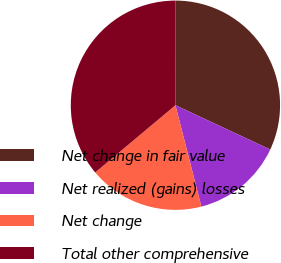<chart> <loc_0><loc_0><loc_500><loc_500><pie_chart><fcel>Net change in fair value<fcel>Net realized (gains) losses<fcel>Net change<fcel>Total other comprehensive<nl><fcel>31.94%<fcel>14.06%<fcel>17.88%<fcel>36.12%<nl></chart> 